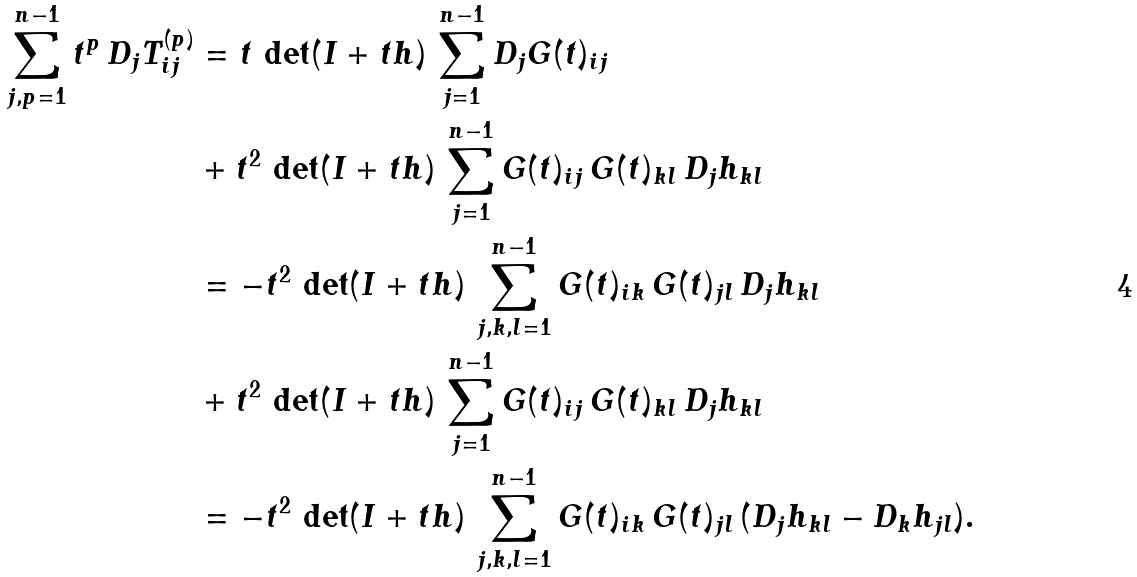<formula> <loc_0><loc_0><loc_500><loc_500>\sum _ { j , p = 1 } ^ { n - 1 } t ^ { p } \, D _ { j } T _ { i j } ^ { ( p ) } & = t \, \det ( I + t h ) \, \sum _ { j = 1 } ^ { n - 1 } D _ { j } G ( t ) _ { i j } \\ & + t ^ { 2 } \, \det ( I + t h ) \, \sum _ { j = 1 } ^ { n - 1 } G ( t ) _ { i j } \, G ( t ) _ { k l } \, D _ { j } h _ { k l } \\ & = - t ^ { 2 } \, \det ( I + t h ) \, \sum _ { j , k , l = 1 } ^ { n - 1 } G ( t ) _ { i k } \, G ( t ) _ { j l } \, D _ { j } h _ { k l } \\ & + t ^ { 2 } \, \det ( I + t h ) \, \sum _ { j = 1 } ^ { n - 1 } G ( t ) _ { i j } \, G ( t ) _ { k l } \, D _ { j } h _ { k l } \\ & = - t ^ { 2 } \, \det ( I + t h ) \, \sum _ { j , k , l = 1 } ^ { n - 1 } G ( t ) _ { i k } \, G ( t ) _ { j l } \, ( D _ { j } h _ { k l } - D _ { k } h _ { j l } ) .</formula> 